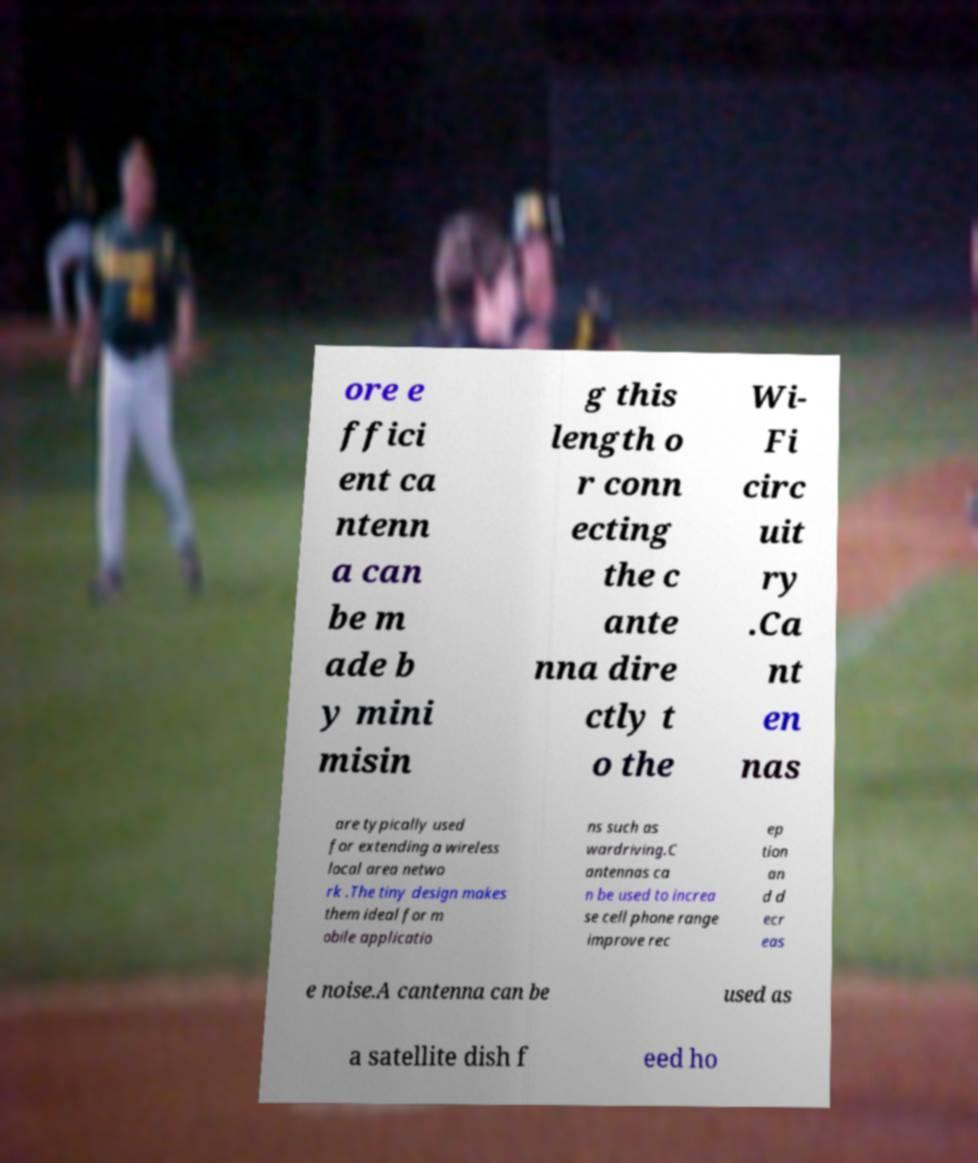Can you accurately transcribe the text from the provided image for me? ore e ffici ent ca ntenn a can be m ade b y mini misin g this length o r conn ecting the c ante nna dire ctly t o the Wi- Fi circ uit ry .Ca nt en nas are typically used for extending a wireless local area netwo rk .The tiny design makes them ideal for m obile applicatio ns such as wardriving.C antennas ca n be used to increa se cell phone range improve rec ep tion an d d ecr eas e noise.A cantenna can be used as a satellite dish f eed ho 